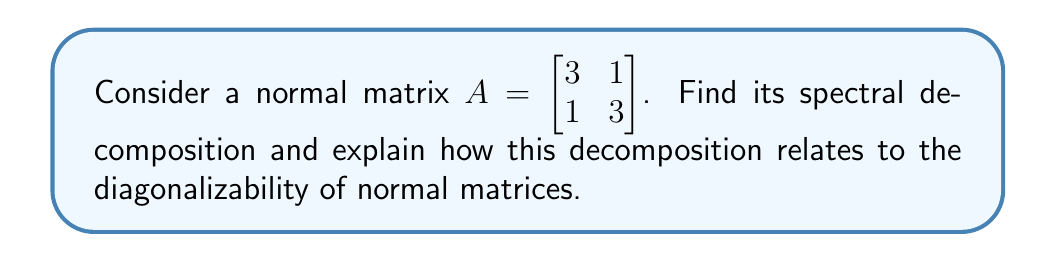Could you help me with this problem? 1) First, let's find the eigenvalues of $A$:
   $\det(A - \lambda I) = \begin{vmatrix} 3-\lambda & 1 \\ 1 & 3-\lambda \end{vmatrix} = (3-\lambda)^2 - 1 = \lambda^2 - 6\lambda + 8 = 0$
   Solving this equation, we get $\lambda_1 = 4$ and $\lambda_2 = 2$

2) Now, let's find the eigenvectors:
   For $\lambda_1 = 4$: $(A - 4I)\mathbf{v}_1 = \mathbf{0}$
   $\begin{bmatrix} -1 & 1 \\ 1 & -1 \end{bmatrix}\begin{bmatrix} v_1 \\ v_2 \end{bmatrix} = \begin{bmatrix} 0 \\ 0 \end{bmatrix}$
   This gives us $\mathbf{v}_1 = \begin{bmatrix} 1 \\ 1 \end{bmatrix}$

   For $\lambda_2 = 2$: $(A - 2I)\mathbf{v}_2 = \mathbf{0}$
   $\begin{bmatrix} 1 & 1 \\ 1 & 1 \end{bmatrix}\begin{bmatrix} v_1 \\ v_2 \end{bmatrix} = \begin{bmatrix} 0 \\ 0 \end{bmatrix}$
   This gives us $\mathbf{v}_2 = \begin{bmatrix} -1 \\ 1 \end{bmatrix}$

3) The spectral decomposition of $A$ is:
   $A = \lambda_1 \mathbf{u}_1\mathbf{u}_1^* + \lambda_2 \mathbf{u}_2\mathbf{u}_2^*$
   where $\mathbf{u}_1$ and $\mathbf{u}_2$ are the normalized eigenvectors:
   $\mathbf{u}_1 = \frac{1}{\sqrt{2}}\begin{bmatrix} 1 \\ 1 \end{bmatrix}$ and $\mathbf{u}_2 = \frac{1}{\sqrt{2}}\begin{bmatrix} -1 \\ 1 \end{bmatrix}$

4) Therefore, the spectral decomposition is:
   $A = 4 \cdot \frac{1}{2}\begin{bmatrix} 1 & 1 \\ 1 & 1 \end{bmatrix} + 2 \cdot \frac{1}{2}\begin{bmatrix} 1 & -1 \\ -1 & 1 \end{bmatrix}$

5) This decomposition demonstrates that $A$ can be written as $A = UDU^*$, where:
   $U = \begin{bmatrix} \frac{1}{\sqrt{2}} & -\frac{1}{\sqrt{2}} \\ \frac{1}{\sqrt{2}} & \frac{1}{\sqrt{2}} \end{bmatrix}$ and $D = \begin{bmatrix} 4 & 0 \\ 0 & 2 \end{bmatrix}$

6) The existence of this decomposition proves that $A$ is diagonalizable. In fact, all normal matrices are diagonalizable, and their eigenvectors form an orthonormal basis for the vector space.

7) The spectral decomposition also shows that normal matrices can be expressed as a linear combination of orthogonal projections onto their eigenspaces, weighted by their respective eigenvalues.
Answer: $A = 4 \cdot \frac{1}{2}\begin{bmatrix} 1 & 1 \\ 1 & 1 \end{bmatrix} + 2 \cdot \frac{1}{2}\begin{bmatrix} 1 & -1 \\ -1 & 1 \end{bmatrix}$ 